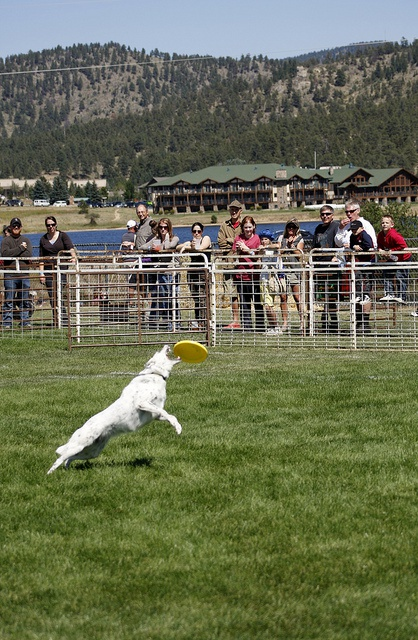Describe the objects in this image and their specific colors. I can see dog in darkgray, white, gray, and darkgreen tones, people in darkgray, black, gray, and maroon tones, people in darkgray, black, gray, lightgray, and maroon tones, people in darkgray, black, gray, and lightgray tones, and people in darkgray, black, gray, and maroon tones in this image. 